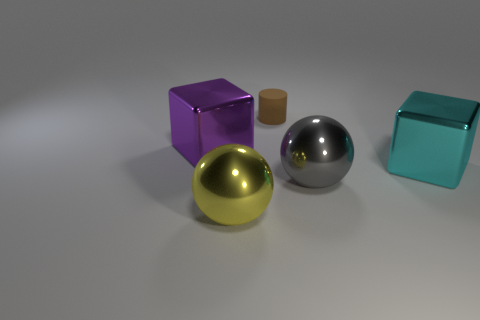Add 5 metallic balls. How many objects exist? 10 Subtract 1 balls. How many balls are left? 1 Subtract all cylinders. How many objects are left? 4 Subtract all large yellow things. Subtract all large objects. How many objects are left? 0 Add 3 small brown cylinders. How many small brown cylinders are left? 4 Add 3 yellow balls. How many yellow balls exist? 4 Subtract 0 blue cubes. How many objects are left? 5 Subtract all yellow cubes. Subtract all yellow cylinders. How many cubes are left? 2 